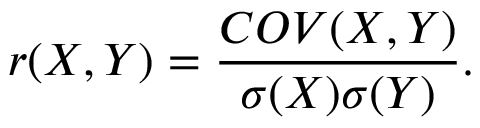Convert formula to latex. <formula><loc_0><loc_0><loc_500><loc_500>r ( X , Y ) = \frac { C O V ( X , Y ) } { \sigma ( X ) \sigma ( Y ) } .</formula> 